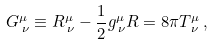Convert formula to latex. <formula><loc_0><loc_0><loc_500><loc_500>G ^ { \mu } _ { \, \nu } \equiv R ^ { \mu } _ { \, \nu } - \frac { 1 } { 2 } g ^ { \mu } _ { \, \nu } R = 8 \pi T ^ { \mu } _ { \, \nu } \, ,</formula> 